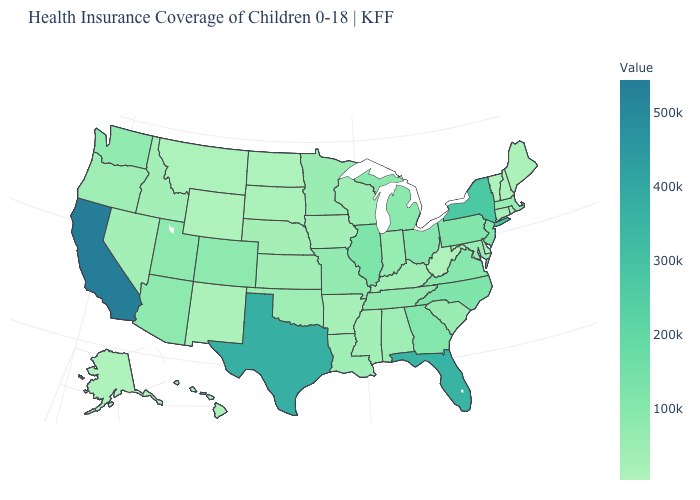Does the map have missing data?
Write a very short answer. No. Does the map have missing data?
Short answer required. No. Does Wisconsin have the lowest value in the USA?
Keep it brief. No. Which states have the lowest value in the USA?
Short answer required. Vermont. Is the legend a continuous bar?
Concise answer only. Yes. 